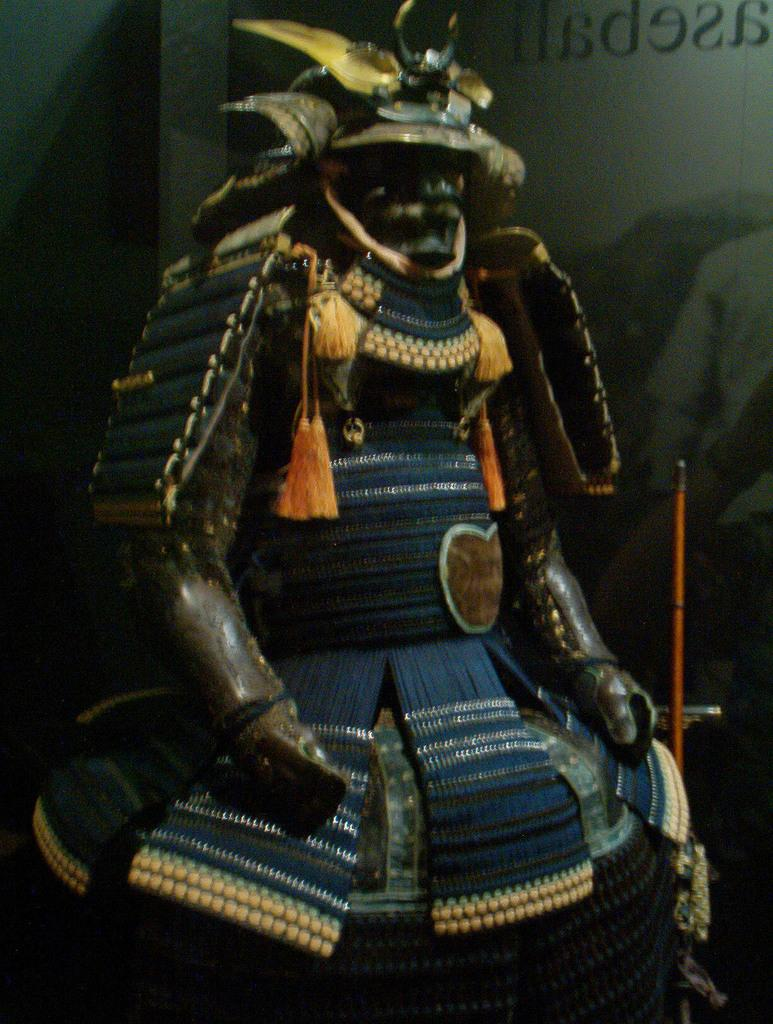What type of artwork is depicted in the image? The image appears to be a sculpture. What material is the sculpture likely made of? The sculpture is likely made of wood. What other object can be seen in the image besides the sculpture? There is a poster in the image. What type of decorative elements are present in the image? There are tassels in the image, and they are orange in color. How does the sculpture stop people from walking on the sidewalk in the image? The image does not depict a sculpture that stops people from walking on a sidewalk, nor is there any mention of a sidewalk in the provided facts. 